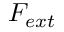<formula> <loc_0><loc_0><loc_500><loc_500>F _ { e x t }</formula> 